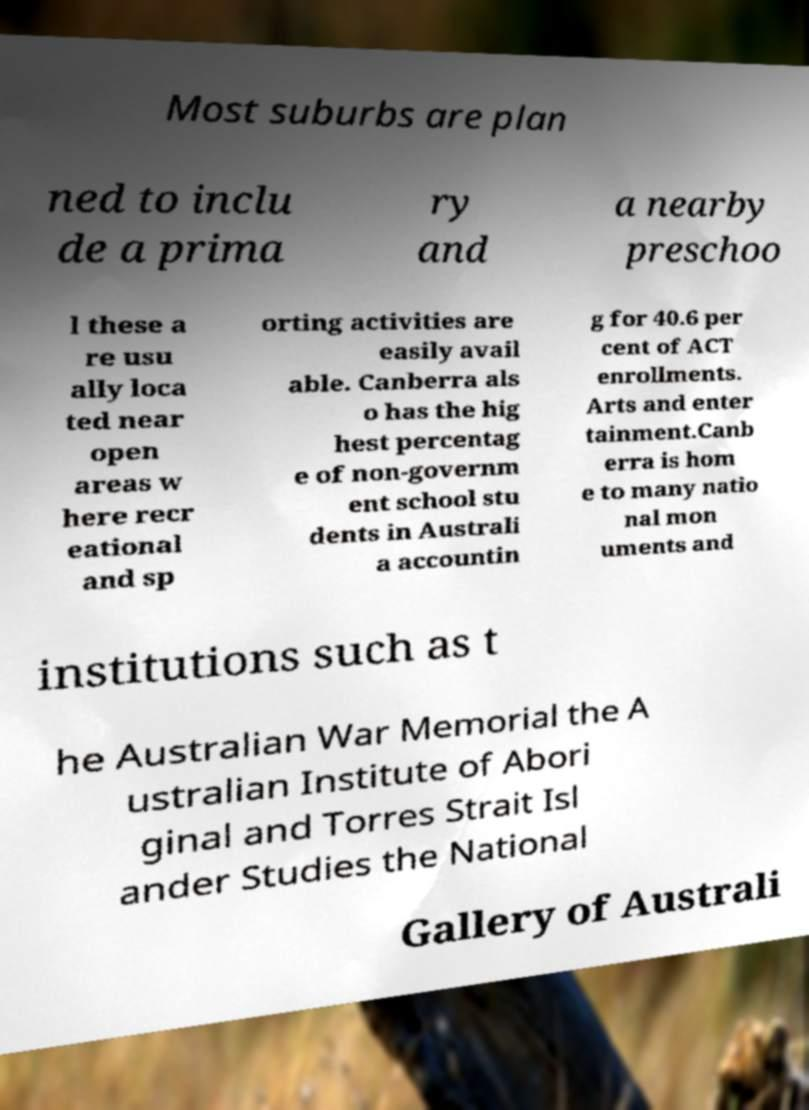Could you assist in decoding the text presented in this image and type it out clearly? Most suburbs are plan ned to inclu de a prima ry and a nearby preschoo l these a re usu ally loca ted near open areas w here recr eational and sp orting activities are easily avail able. Canberra als o has the hig hest percentag e of non-governm ent school stu dents in Australi a accountin g for 40.6 per cent of ACT enrollments. Arts and enter tainment.Canb erra is hom e to many natio nal mon uments and institutions such as t he Australian War Memorial the A ustralian Institute of Abori ginal and Torres Strait Isl ander Studies the National Gallery of Australi 